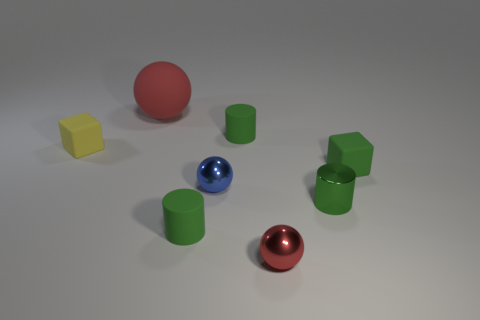Subtract all purple cubes. How many red balls are left? 2 Subtract all large red balls. How many balls are left? 2 Add 1 cyan cylinders. How many objects exist? 9 Subtract 2 balls. How many balls are left? 1 Subtract all cubes. How many objects are left? 6 Add 2 spheres. How many spheres are left? 5 Add 1 green matte cylinders. How many green matte cylinders exist? 3 Subtract 0 blue cubes. How many objects are left? 8 Subtract all brown cubes. Subtract all red spheres. How many cubes are left? 2 Subtract all blue metallic objects. Subtract all rubber cylinders. How many objects are left? 5 